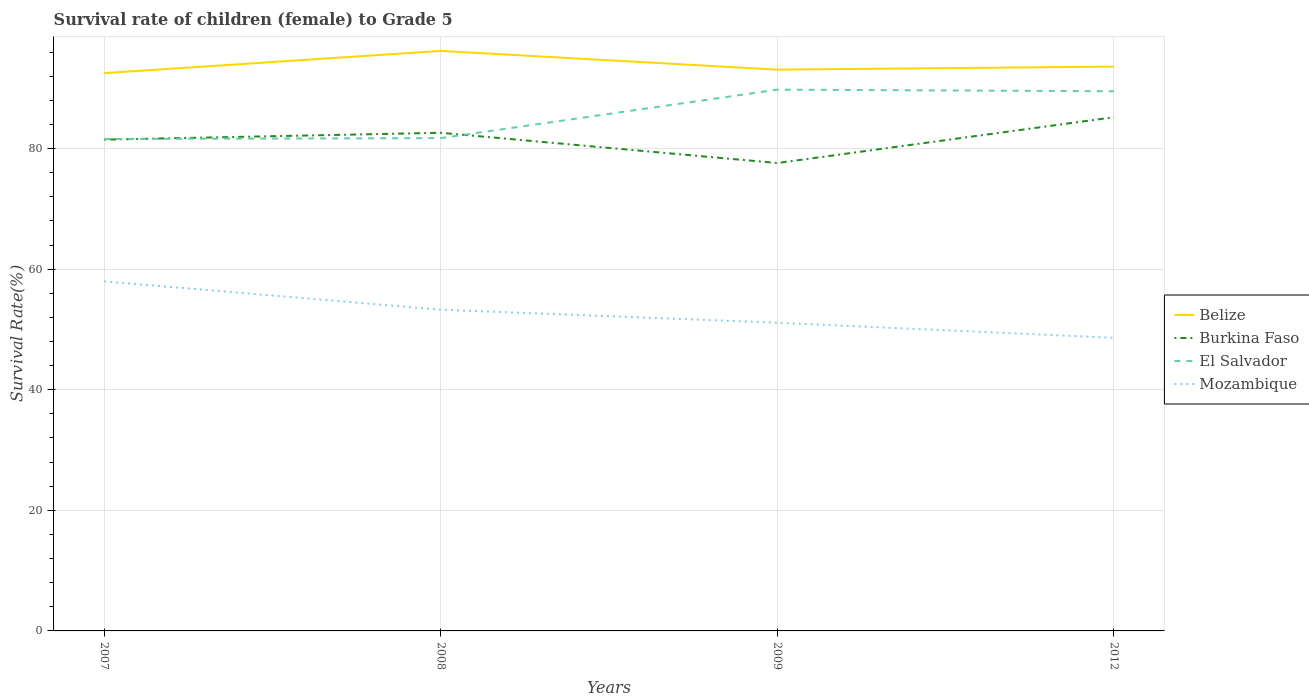Does the line corresponding to Burkina Faso intersect with the line corresponding to Mozambique?
Your answer should be very brief. No. Across all years, what is the maximum survival rate of female children to grade 5 in Burkina Faso?
Provide a short and direct response. 77.6. In which year was the survival rate of female children to grade 5 in El Salvador maximum?
Make the answer very short. 2007. What is the total survival rate of female children to grade 5 in Belize in the graph?
Offer a very short reply. -0.57. What is the difference between the highest and the second highest survival rate of female children to grade 5 in Mozambique?
Your response must be concise. 9.36. How many years are there in the graph?
Your answer should be compact. 4. Are the values on the major ticks of Y-axis written in scientific E-notation?
Provide a short and direct response. No. Where does the legend appear in the graph?
Offer a very short reply. Center right. How are the legend labels stacked?
Give a very brief answer. Vertical. What is the title of the graph?
Make the answer very short. Survival rate of children (female) to Grade 5. What is the label or title of the Y-axis?
Offer a very short reply. Survival Rate(%). What is the Survival Rate(%) in Belize in 2007?
Your answer should be compact. 92.51. What is the Survival Rate(%) of Burkina Faso in 2007?
Keep it short and to the point. 81.48. What is the Survival Rate(%) in El Salvador in 2007?
Provide a succinct answer. 81.59. What is the Survival Rate(%) in Mozambique in 2007?
Provide a succinct answer. 57.97. What is the Survival Rate(%) in Belize in 2008?
Give a very brief answer. 96.19. What is the Survival Rate(%) of Burkina Faso in 2008?
Provide a succinct answer. 82.62. What is the Survival Rate(%) in El Salvador in 2008?
Your response must be concise. 81.73. What is the Survival Rate(%) in Mozambique in 2008?
Provide a short and direct response. 53.28. What is the Survival Rate(%) of Belize in 2009?
Keep it short and to the point. 93.09. What is the Survival Rate(%) in Burkina Faso in 2009?
Your response must be concise. 77.6. What is the Survival Rate(%) of El Salvador in 2009?
Keep it short and to the point. 89.77. What is the Survival Rate(%) of Mozambique in 2009?
Make the answer very short. 51.12. What is the Survival Rate(%) of Belize in 2012?
Your response must be concise. 93.59. What is the Survival Rate(%) in Burkina Faso in 2012?
Give a very brief answer. 85.2. What is the Survival Rate(%) of El Salvador in 2012?
Offer a very short reply. 89.5. What is the Survival Rate(%) of Mozambique in 2012?
Provide a short and direct response. 48.61. Across all years, what is the maximum Survival Rate(%) in Belize?
Give a very brief answer. 96.19. Across all years, what is the maximum Survival Rate(%) of Burkina Faso?
Give a very brief answer. 85.2. Across all years, what is the maximum Survival Rate(%) of El Salvador?
Your response must be concise. 89.77. Across all years, what is the maximum Survival Rate(%) in Mozambique?
Give a very brief answer. 57.97. Across all years, what is the minimum Survival Rate(%) in Belize?
Your answer should be compact. 92.51. Across all years, what is the minimum Survival Rate(%) of Burkina Faso?
Your answer should be very brief. 77.6. Across all years, what is the minimum Survival Rate(%) of El Salvador?
Your response must be concise. 81.59. Across all years, what is the minimum Survival Rate(%) of Mozambique?
Give a very brief answer. 48.61. What is the total Survival Rate(%) in Belize in the graph?
Give a very brief answer. 375.39. What is the total Survival Rate(%) of Burkina Faso in the graph?
Ensure brevity in your answer.  326.9. What is the total Survival Rate(%) of El Salvador in the graph?
Your answer should be very brief. 342.6. What is the total Survival Rate(%) in Mozambique in the graph?
Offer a terse response. 210.98. What is the difference between the Survival Rate(%) of Belize in 2007 and that in 2008?
Your response must be concise. -3.68. What is the difference between the Survival Rate(%) in Burkina Faso in 2007 and that in 2008?
Provide a short and direct response. -1.14. What is the difference between the Survival Rate(%) of El Salvador in 2007 and that in 2008?
Offer a terse response. -0.15. What is the difference between the Survival Rate(%) in Mozambique in 2007 and that in 2008?
Your answer should be very brief. 4.7. What is the difference between the Survival Rate(%) in Belize in 2007 and that in 2009?
Provide a succinct answer. -0.57. What is the difference between the Survival Rate(%) of Burkina Faso in 2007 and that in 2009?
Make the answer very short. 3.88. What is the difference between the Survival Rate(%) of El Salvador in 2007 and that in 2009?
Make the answer very short. -8.19. What is the difference between the Survival Rate(%) of Mozambique in 2007 and that in 2009?
Your answer should be very brief. 6.86. What is the difference between the Survival Rate(%) in Belize in 2007 and that in 2012?
Make the answer very short. -1.08. What is the difference between the Survival Rate(%) in Burkina Faso in 2007 and that in 2012?
Give a very brief answer. -3.72. What is the difference between the Survival Rate(%) in El Salvador in 2007 and that in 2012?
Offer a very short reply. -7.92. What is the difference between the Survival Rate(%) of Mozambique in 2007 and that in 2012?
Ensure brevity in your answer.  9.36. What is the difference between the Survival Rate(%) of Belize in 2008 and that in 2009?
Your response must be concise. 3.11. What is the difference between the Survival Rate(%) of Burkina Faso in 2008 and that in 2009?
Your answer should be compact. 5.02. What is the difference between the Survival Rate(%) of El Salvador in 2008 and that in 2009?
Your answer should be compact. -8.04. What is the difference between the Survival Rate(%) of Mozambique in 2008 and that in 2009?
Ensure brevity in your answer.  2.16. What is the difference between the Survival Rate(%) in Belize in 2008 and that in 2012?
Your answer should be compact. 2.6. What is the difference between the Survival Rate(%) of Burkina Faso in 2008 and that in 2012?
Offer a very short reply. -2.58. What is the difference between the Survival Rate(%) of El Salvador in 2008 and that in 2012?
Your answer should be very brief. -7.77. What is the difference between the Survival Rate(%) of Mozambique in 2008 and that in 2012?
Your response must be concise. 4.66. What is the difference between the Survival Rate(%) in Belize in 2009 and that in 2012?
Offer a very short reply. -0.5. What is the difference between the Survival Rate(%) of Burkina Faso in 2009 and that in 2012?
Ensure brevity in your answer.  -7.6. What is the difference between the Survival Rate(%) of El Salvador in 2009 and that in 2012?
Ensure brevity in your answer.  0.27. What is the difference between the Survival Rate(%) of Mozambique in 2009 and that in 2012?
Offer a terse response. 2.5. What is the difference between the Survival Rate(%) in Belize in 2007 and the Survival Rate(%) in Burkina Faso in 2008?
Your answer should be compact. 9.9. What is the difference between the Survival Rate(%) in Belize in 2007 and the Survival Rate(%) in El Salvador in 2008?
Your answer should be very brief. 10.78. What is the difference between the Survival Rate(%) in Belize in 2007 and the Survival Rate(%) in Mozambique in 2008?
Your answer should be very brief. 39.24. What is the difference between the Survival Rate(%) in Burkina Faso in 2007 and the Survival Rate(%) in El Salvador in 2008?
Your answer should be compact. -0.25. What is the difference between the Survival Rate(%) of Burkina Faso in 2007 and the Survival Rate(%) of Mozambique in 2008?
Make the answer very short. 28.21. What is the difference between the Survival Rate(%) of El Salvador in 2007 and the Survival Rate(%) of Mozambique in 2008?
Offer a terse response. 28.31. What is the difference between the Survival Rate(%) of Belize in 2007 and the Survival Rate(%) of Burkina Faso in 2009?
Keep it short and to the point. 14.91. What is the difference between the Survival Rate(%) in Belize in 2007 and the Survival Rate(%) in El Salvador in 2009?
Offer a terse response. 2.74. What is the difference between the Survival Rate(%) in Belize in 2007 and the Survival Rate(%) in Mozambique in 2009?
Give a very brief answer. 41.4. What is the difference between the Survival Rate(%) in Burkina Faso in 2007 and the Survival Rate(%) in El Salvador in 2009?
Your answer should be compact. -8.29. What is the difference between the Survival Rate(%) of Burkina Faso in 2007 and the Survival Rate(%) of Mozambique in 2009?
Give a very brief answer. 30.37. What is the difference between the Survival Rate(%) in El Salvador in 2007 and the Survival Rate(%) in Mozambique in 2009?
Provide a short and direct response. 30.47. What is the difference between the Survival Rate(%) in Belize in 2007 and the Survival Rate(%) in Burkina Faso in 2012?
Offer a very short reply. 7.32. What is the difference between the Survival Rate(%) of Belize in 2007 and the Survival Rate(%) of El Salvador in 2012?
Provide a short and direct response. 3.01. What is the difference between the Survival Rate(%) in Belize in 2007 and the Survival Rate(%) in Mozambique in 2012?
Make the answer very short. 43.9. What is the difference between the Survival Rate(%) in Burkina Faso in 2007 and the Survival Rate(%) in El Salvador in 2012?
Ensure brevity in your answer.  -8.02. What is the difference between the Survival Rate(%) in Burkina Faso in 2007 and the Survival Rate(%) in Mozambique in 2012?
Offer a very short reply. 32.87. What is the difference between the Survival Rate(%) in El Salvador in 2007 and the Survival Rate(%) in Mozambique in 2012?
Offer a terse response. 32.98. What is the difference between the Survival Rate(%) of Belize in 2008 and the Survival Rate(%) of Burkina Faso in 2009?
Make the answer very short. 18.59. What is the difference between the Survival Rate(%) of Belize in 2008 and the Survival Rate(%) of El Salvador in 2009?
Offer a very short reply. 6.42. What is the difference between the Survival Rate(%) of Belize in 2008 and the Survival Rate(%) of Mozambique in 2009?
Your answer should be compact. 45.08. What is the difference between the Survival Rate(%) of Burkina Faso in 2008 and the Survival Rate(%) of El Salvador in 2009?
Offer a terse response. -7.16. What is the difference between the Survival Rate(%) in Burkina Faso in 2008 and the Survival Rate(%) in Mozambique in 2009?
Ensure brevity in your answer.  31.5. What is the difference between the Survival Rate(%) of El Salvador in 2008 and the Survival Rate(%) of Mozambique in 2009?
Provide a short and direct response. 30.62. What is the difference between the Survival Rate(%) in Belize in 2008 and the Survival Rate(%) in Burkina Faso in 2012?
Provide a succinct answer. 11. What is the difference between the Survival Rate(%) in Belize in 2008 and the Survival Rate(%) in El Salvador in 2012?
Your answer should be compact. 6.69. What is the difference between the Survival Rate(%) in Belize in 2008 and the Survival Rate(%) in Mozambique in 2012?
Keep it short and to the point. 47.58. What is the difference between the Survival Rate(%) in Burkina Faso in 2008 and the Survival Rate(%) in El Salvador in 2012?
Your response must be concise. -6.89. What is the difference between the Survival Rate(%) in Burkina Faso in 2008 and the Survival Rate(%) in Mozambique in 2012?
Provide a succinct answer. 34. What is the difference between the Survival Rate(%) of El Salvador in 2008 and the Survival Rate(%) of Mozambique in 2012?
Make the answer very short. 33.12. What is the difference between the Survival Rate(%) of Belize in 2009 and the Survival Rate(%) of Burkina Faso in 2012?
Offer a terse response. 7.89. What is the difference between the Survival Rate(%) in Belize in 2009 and the Survival Rate(%) in El Salvador in 2012?
Provide a succinct answer. 3.58. What is the difference between the Survival Rate(%) in Belize in 2009 and the Survival Rate(%) in Mozambique in 2012?
Ensure brevity in your answer.  44.47. What is the difference between the Survival Rate(%) in Burkina Faso in 2009 and the Survival Rate(%) in El Salvador in 2012?
Make the answer very short. -11.9. What is the difference between the Survival Rate(%) in Burkina Faso in 2009 and the Survival Rate(%) in Mozambique in 2012?
Give a very brief answer. 28.99. What is the difference between the Survival Rate(%) of El Salvador in 2009 and the Survival Rate(%) of Mozambique in 2012?
Provide a short and direct response. 41.16. What is the average Survival Rate(%) of Belize per year?
Keep it short and to the point. 93.85. What is the average Survival Rate(%) of Burkina Faso per year?
Offer a terse response. 81.72. What is the average Survival Rate(%) in El Salvador per year?
Offer a terse response. 85.65. What is the average Survival Rate(%) in Mozambique per year?
Your answer should be very brief. 52.74. In the year 2007, what is the difference between the Survival Rate(%) of Belize and Survival Rate(%) of Burkina Faso?
Your answer should be compact. 11.03. In the year 2007, what is the difference between the Survival Rate(%) in Belize and Survival Rate(%) in El Salvador?
Your response must be concise. 10.93. In the year 2007, what is the difference between the Survival Rate(%) of Belize and Survival Rate(%) of Mozambique?
Give a very brief answer. 34.54. In the year 2007, what is the difference between the Survival Rate(%) of Burkina Faso and Survival Rate(%) of El Salvador?
Provide a short and direct response. -0.11. In the year 2007, what is the difference between the Survival Rate(%) in Burkina Faso and Survival Rate(%) in Mozambique?
Make the answer very short. 23.51. In the year 2007, what is the difference between the Survival Rate(%) in El Salvador and Survival Rate(%) in Mozambique?
Provide a short and direct response. 23.61. In the year 2008, what is the difference between the Survival Rate(%) in Belize and Survival Rate(%) in Burkina Faso?
Keep it short and to the point. 13.58. In the year 2008, what is the difference between the Survival Rate(%) in Belize and Survival Rate(%) in El Salvador?
Your answer should be very brief. 14.46. In the year 2008, what is the difference between the Survival Rate(%) of Belize and Survival Rate(%) of Mozambique?
Your response must be concise. 42.92. In the year 2008, what is the difference between the Survival Rate(%) of Burkina Faso and Survival Rate(%) of El Salvador?
Provide a succinct answer. 0.88. In the year 2008, what is the difference between the Survival Rate(%) in Burkina Faso and Survival Rate(%) in Mozambique?
Your answer should be very brief. 29.34. In the year 2008, what is the difference between the Survival Rate(%) in El Salvador and Survival Rate(%) in Mozambique?
Provide a short and direct response. 28.46. In the year 2009, what is the difference between the Survival Rate(%) in Belize and Survival Rate(%) in Burkina Faso?
Offer a very short reply. 15.49. In the year 2009, what is the difference between the Survival Rate(%) of Belize and Survival Rate(%) of El Salvador?
Your response must be concise. 3.31. In the year 2009, what is the difference between the Survival Rate(%) in Belize and Survival Rate(%) in Mozambique?
Make the answer very short. 41.97. In the year 2009, what is the difference between the Survival Rate(%) of Burkina Faso and Survival Rate(%) of El Salvador?
Offer a terse response. -12.17. In the year 2009, what is the difference between the Survival Rate(%) in Burkina Faso and Survival Rate(%) in Mozambique?
Your answer should be compact. 26.48. In the year 2009, what is the difference between the Survival Rate(%) in El Salvador and Survival Rate(%) in Mozambique?
Provide a succinct answer. 38.66. In the year 2012, what is the difference between the Survival Rate(%) in Belize and Survival Rate(%) in Burkina Faso?
Provide a short and direct response. 8.39. In the year 2012, what is the difference between the Survival Rate(%) of Belize and Survival Rate(%) of El Salvador?
Keep it short and to the point. 4.09. In the year 2012, what is the difference between the Survival Rate(%) of Belize and Survival Rate(%) of Mozambique?
Make the answer very short. 44.98. In the year 2012, what is the difference between the Survival Rate(%) in Burkina Faso and Survival Rate(%) in El Salvador?
Give a very brief answer. -4.31. In the year 2012, what is the difference between the Survival Rate(%) of Burkina Faso and Survival Rate(%) of Mozambique?
Provide a short and direct response. 36.59. In the year 2012, what is the difference between the Survival Rate(%) in El Salvador and Survival Rate(%) in Mozambique?
Offer a very short reply. 40.89. What is the ratio of the Survival Rate(%) of Belize in 2007 to that in 2008?
Give a very brief answer. 0.96. What is the ratio of the Survival Rate(%) of Burkina Faso in 2007 to that in 2008?
Your response must be concise. 0.99. What is the ratio of the Survival Rate(%) in El Salvador in 2007 to that in 2008?
Your response must be concise. 1. What is the ratio of the Survival Rate(%) of Mozambique in 2007 to that in 2008?
Give a very brief answer. 1.09. What is the ratio of the Survival Rate(%) of Belize in 2007 to that in 2009?
Provide a short and direct response. 0.99. What is the ratio of the Survival Rate(%) in El Salvador in 2007 to that in 2009?
Make the answer very short. 0.91. What is the ratio of the Survival Rate(%) in Mozambique in 2007 to that in 2009?
Your answer should be very brief. 1.13. What is the ratio of the Survival Rate(%) in Belize in 2007 to that in 2012?
Your answer should be compact. 0.99. What is the ratio of the Survival Rate(%) in Burkina Faso in 2007 to that in 2012?
Your answer should be very brief. 0.96. What is the ratio of the Survival Rate(%) of El Salvador in 2007 to that in 2012?
Your answer should be very brief. 0.91. What is the ratio of the Survival Rate(%) in Mozambique in 2007 to that in 2012?
Offer a terse response. 1.19. What is the ratio of the Survival Rate(%) of Belize in 2008 to that in 2009?
Your answer should be compact. 1.03. What is the ratio of the Survival Rate(%) of Burkina Faso in 2008 to that in 2009?
Give a very brief answer. 1.06. What is the ratio of the Survival Rate(%) of El Salvador in 2008 to that in 2009?
Offer a terse response. 0.91. What is the ratio of the Survival Rate(%) in Mozambique in 2008 to that in 2009?
Keep it short and to the point. 1.04. What is the ratio of the Survival Rate(%) in Belize in 2008 to that in 2012?
Offer a very short reply. 1.03. What is the ratio of the Survival Rate(%) in Burkina Faso in 2008 to that in 2012?
Your response must be concise. 0.97. What is the ratio of the Survival Rate(%) in El Salvador in 2008 to that in 2012?
Give a very brief answer. 0.91. What is the ratio of the Survival Rate(%) of Mozambique in 2008 to that in 2012?
Offer a terse response. 1.1. What is the ratio of the Survival Rate(%) of Belize in 2009 to that in 2012?
Offer a terse response. 0.99. What is the ratio of the Survival Rate(%) in Burkina Faso in 2009 to that in 2012?
Your answer should be very brief. 0.91. What is the ratio of the Survival Rate(%) of Mozambique in 2009 to that in 2012?
Keep it short and to the point. 1.05. What is the difference between the highest and the second highest Survival Rate(%) in Belize?
Your answer should be very brief. 2.6. What is the difference between the highest and the second highest Survival Rate(%) of Burkina Faso?
Provide a short and direct response. 2.58. What is the difference between the highest and the second highest Survival Rate(%) of El Salvador?
Offer a terse response. 0.27. What is the difference between the highest and the second highest Survival Rate(%) in Mozambique?
Ensure brevity in your answer.  4.7. What is the difference between the highest and the lowest Survival Rate(%) of Belize?
Provide a short and direct response. 3.68. What is the difference between the highest and the lowest Survival Rate(%) in Burkina Faso?
Keep it short and to the point. 7.6. What is the difference between the highest and the lowest Survival Rate(%) of El Salvador?
Ensure brevity in your answer.  8.19. What is the difference between the highest and the lowest Survival Rate(%) in Mozambique?
Your answer should be very brief. 9.36. 